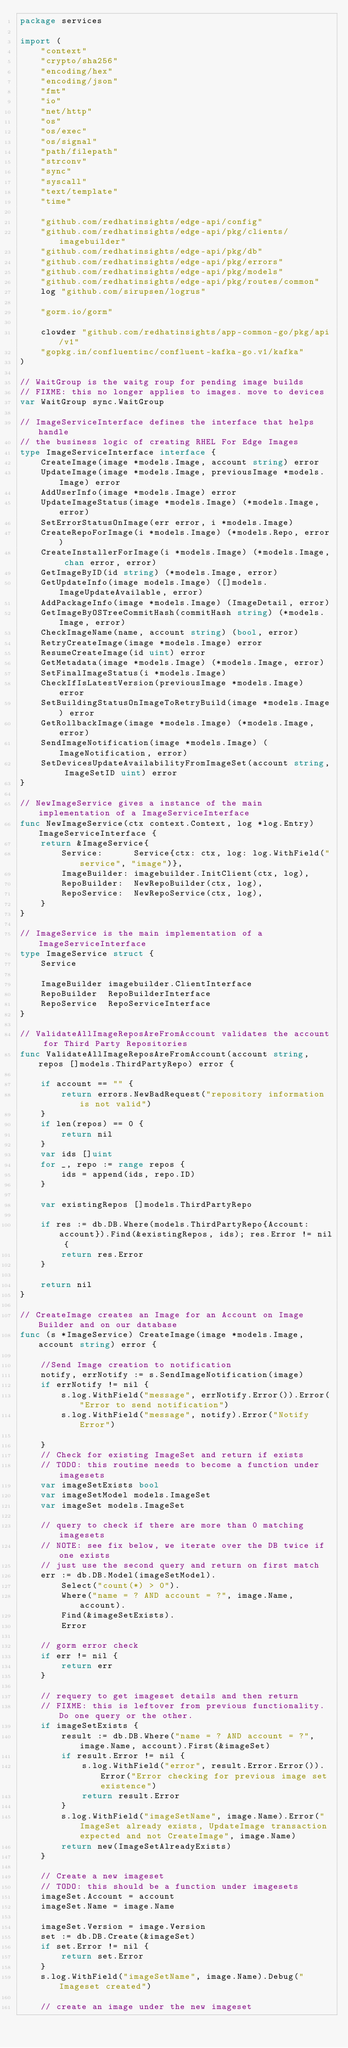Convert code to text. <code><loc_0><loc_0><loc_500><loc_500><_Go_>package services

import (
	"context"
	"crypto/sha256"
	"encoding/hex"
	"encoding/json"
	"fmt"
	"io"
	"net/http"
	"os"
	"os/exec"
	"os/signal"
	"path/filepath"
	"strconv"
	"sync"
	"syscall"
	"text/template"
	"time"

	"github.com/redhatinsights/edge-api/config"
	"github.com/redhatinsights/edge-api/pkg/clients/imagebuilder"
	"github.com/redhatinsights/edge-api/pkg/db"
	"github.com/redhatinsights/edge-api/pkg/errors"
	"github.com/redhatinsights/edge-api/pkg/models"
	"github.com/redhatinsights/edge-api/pkg/routes/common"
	log "github.com/sirupsen/logrus"

	"gorm.io/gorm"

	clowder "github.com/redhatinsights/app-common-go/pkg/api/v1"
	"gopkg.in/confluentinc/confluent-kafka-go.v1/kafka"
)

// WaitGroup is the waitg roup for pending image builds
// FIXME: this no longer applies to images. move to devices
var WaitGroup sync.WaitGroup

// ImageServiceInterface defines the interface that helps handle
// the business logic of creating RHEL For Edge Images
type ImageServiceInterface interface {
	CreateImage(image *models.Image, account string) error
	UpdateImage(image *models.Image, previousImage *models.Image) error
	AddUserInfo(image *models.Image) error
	UpdateImageStatus(image *models.Image) (*models.Image, error)
	SetErrorStatusOnImage(err error, i *models.Image)
	CreateRepoForImage(i *models.Image) (*models.Repo, error)
	CreateInstallerForImage(i *models.Image) (*models.Image, chan error, error)
	GetImageByID(id string) (*models.Image, error)
	GetUpdateInfo(image models.Image) ([]models.ImageUpdateAvailable, error)
	AddPackageInfo(image *models.Image) (ImageDetail, error)
	GetImageByOSTreeCommitHash(commitHash string) (*models.Image, error)
	CheckImageName(name, account string) (bool, error)
	RetryCreateImage(image *models.Image) error
	ResumeCreateImage(id uint) error
	GetMetadata(image *models.Image) (*models.Image, error)
	SetFinalImageStatus(i *models.Image)
	CheckIfIsLatestVersion(previousImage *models.Image) error
	SetBuildingStatusOnImageToRetryBuild(image *models.Image) error
	GetRollbackImage(image *models.Image) (*models.Image, error)
	SendImageNotification(image *models.Image) (ImageNotification, error)
	SetDevicesUpdateAvailabilityFromImageSet(account string, ImageSetID uint) error
}

// NewImageService gives a instance of the main implementation of a ImageServiceInterface
func NewImageService(ctx context.Context, log *log.Entry) ImageServiceInterface {
	return &ImageService{
		Service:      Service{ctx: ctx, log: log.WithField("service", "image")},
		ImageBuilder: imagebuilder.InitClient(ctx, log),
		RepoBuilder:  NewRepoBuilder(ctx, log),
		RepoService:  NewRepoService(ctx, log),
	}
}

// ImageService is the main implementation of a ImageServiceInterface
type ImageService struct {
	Service

	ImageBuilder imagebuilder.ClientInterface
	RepoBuilder  RepoBuilderInterface
	RepoService  RepoServiceInterface
}

// ValidateAllImageReposAreFromAccount validates the account for Third Party Repositories
func ValidateAllImageReposAreFromAccount(account string, repos []models.ThirdPartyRepo) error {

	if account == "" {
		return errors.NewBadRequest("repository information is not valid")
	}
	if len(repos) == 0 {
		return nil
	}
	var ids []uint
	for _, repo := range repos {
		ids = append(ids, repo.ID)
	}

	var existingRepos []models.ThirdPartyRepo

	if res := db.DB.Where(models.ThirdPartyRepo{Account: account}).Find(&existingRepos, ids); res.Error != nil {
		return res.Error
	}

	return nil
}

// CreateImage creates an Image for an Account on Image Builder and on our database
func (s *ImageService) CreateImage(image *models.Image, account string) error {

	//Send Image creation to notification
	notify, errNotify := s.SendImageNotification(image)
	if errNotify != nil {
		s.log.WithField("message", errNotify.Error()).Error("Error to send notification")
		s.log.WithField("message", notify).Error("Notify Error")

	}
	// Check for existing ImageSet and return if exists
	// TODO: this routine needs to become a function under imagesets
	var imageSetExists bool
	var imageSetModel models.ImageSet
	var imageSet models.ImageSet

	// query to check if there are more than 0 matching imagesets
	// NOTE: see fix below, we iterate over the DB twice if one exists
	// just use the second query and return on first match
	err := db.DB.Model(imageSetModel).
		Select("count(*) > 0").
		Where("name = ? AND account = ?", image.Name, account).
		Find(&imageSetExists).
		Error

	// gorm error check
	if err != nil {
		return err
	}

	// requery to get imageset details and then return
	// FIXME: this is leftover from previous functionality. Do one query or the other.
	if imageSetExists {
		result := db.DB.Where("name = ? AND account = ?", image.Name, account).First(&imageSet)
		if result.Error != nil {
			s.log.WithField("error", result.Error.Error()).Error("Error checking for previous image set existence")
			return result.Error
		}
		s.log.WithField("imageSetName", image.Name).Error("ImageSet already exists, UpdateImage transaction expected and not CreateImage", image.Name)
		return new(ImageSetAlreadyExists)
	}

	// Create a new imageset
	// TODO: this should be a function under imagesets
	imageSet.Account = account
	imageSet.Name = image.Name

	imageSet.Version = image.Version
	set := db.DB.Create(&imageSet)
	if set.Error != nil {
		return set.Error
	}
	s.log.WithField("imageSetName", image.Name).Debug("Imageset created")

	// create an image under the new imageset</code> 